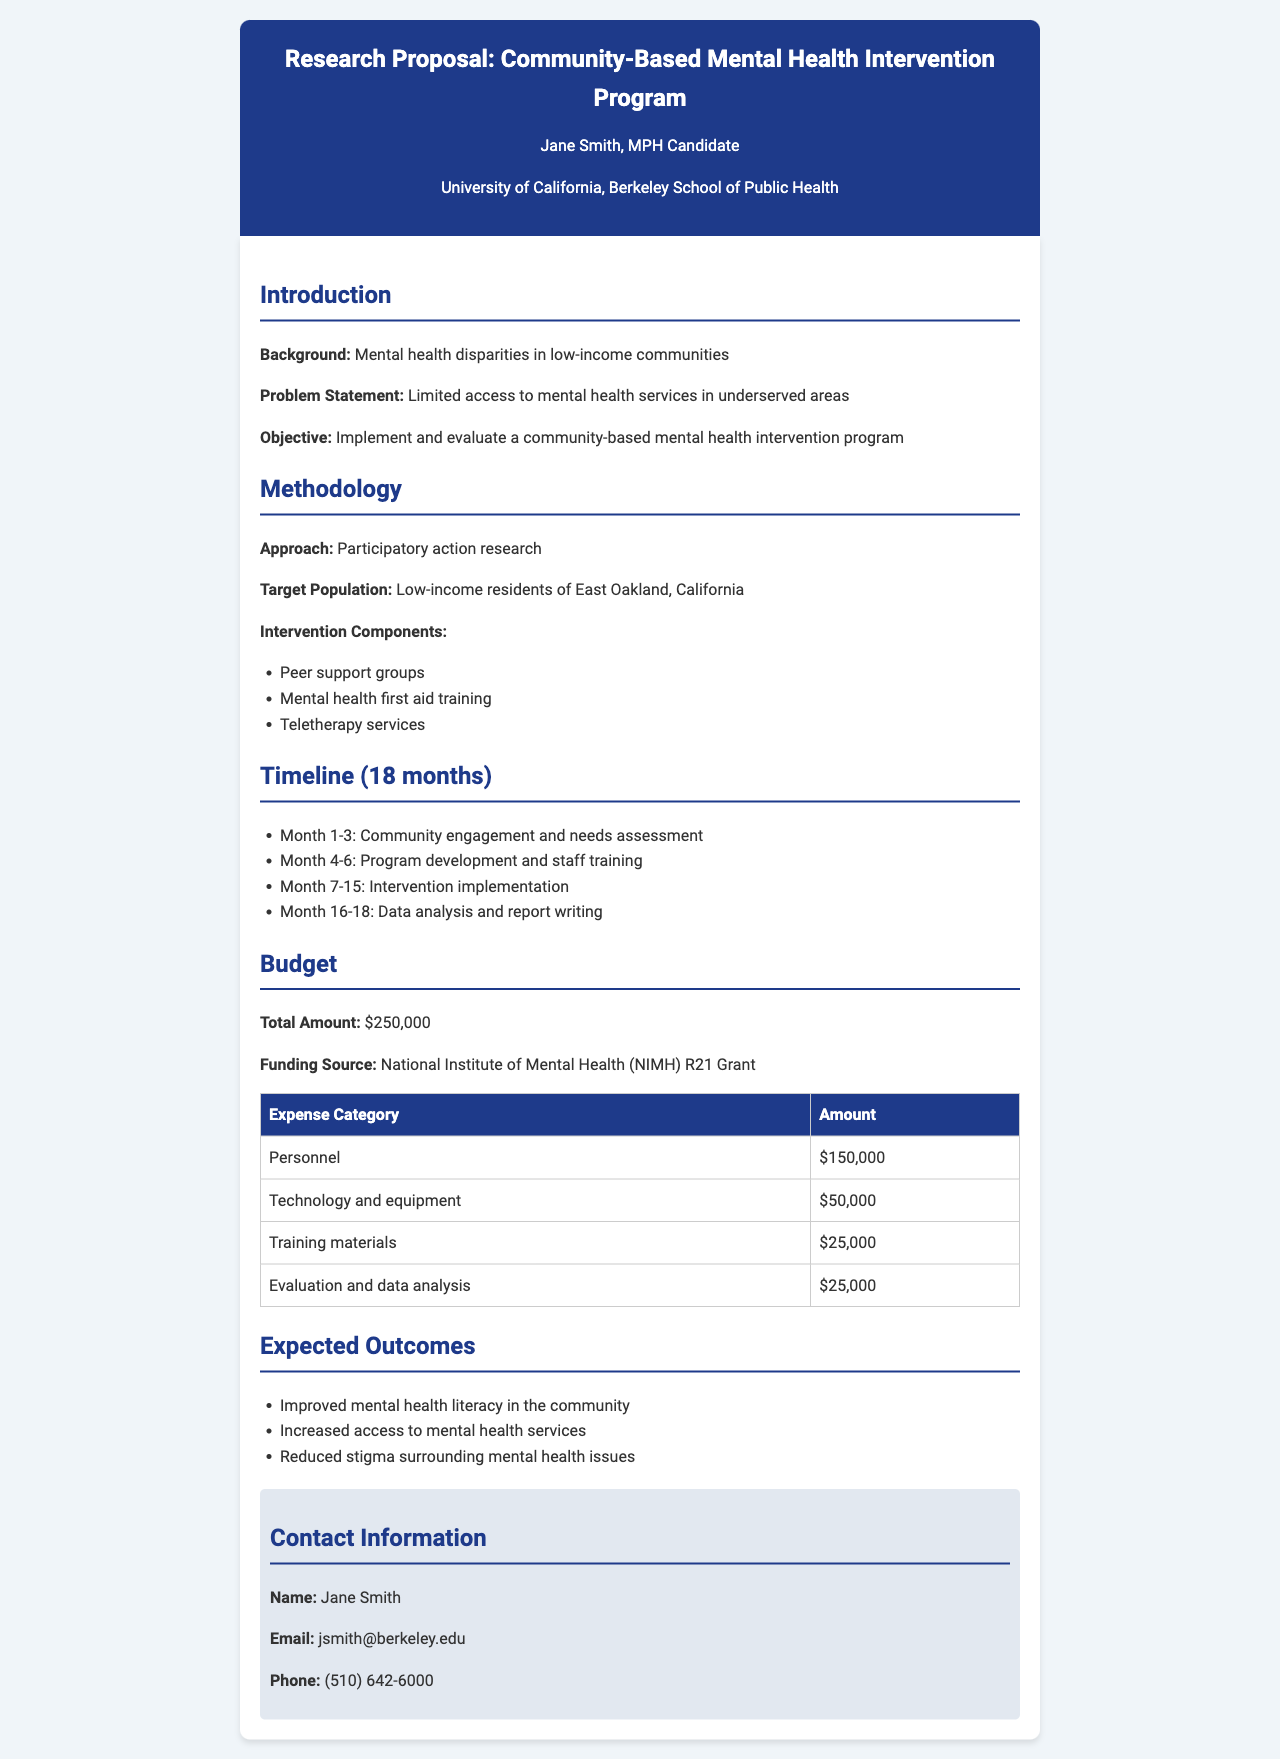What is the total budget for the program? The total budget is presented in the budget section, which specifies a total amount of $250,000.
Answer: $250,000 Who is the funding source for the program? The funding source is explicitly mentioned in the budget section as the National Institute of Mental Health (NIMH) R21 Grant.
Answer: National Institute of Mental Health (NIMH) R21 Grant What are the intervention components? The document lists the intervention components as peer support groups, mental health first aid training, and teletherapy services.
Answer: Peer support groups, mental health first aid training, teletherapy services What is the duration of the timeline for the project? The timeline section outlines the duration of the project as 18 months.
Answer: 18 months Which population is the target for this intervention program? The target population is specified in the methodology section as low-income residents of East Oakland, California.
Answer: Low-income residents of East Oakland, California What are the expected outcomes of the program? Expected outcomes include improved mental health literacy, increased access to services, and reduced stigma.
Answer: Improved mental health literacy, increased access to mental health services, reduced stigma In which month does the community engagement and needs assessment take place? The document states that community engagement and needs assessment occur during the first three months (Month 1-3) of the timeline.
Answer: Month 1-3 What is the contact email provided in the document? The contact information section includes Jane Smith's email, which is stated clearly.
Answer: jsmith@berkeley.edu 